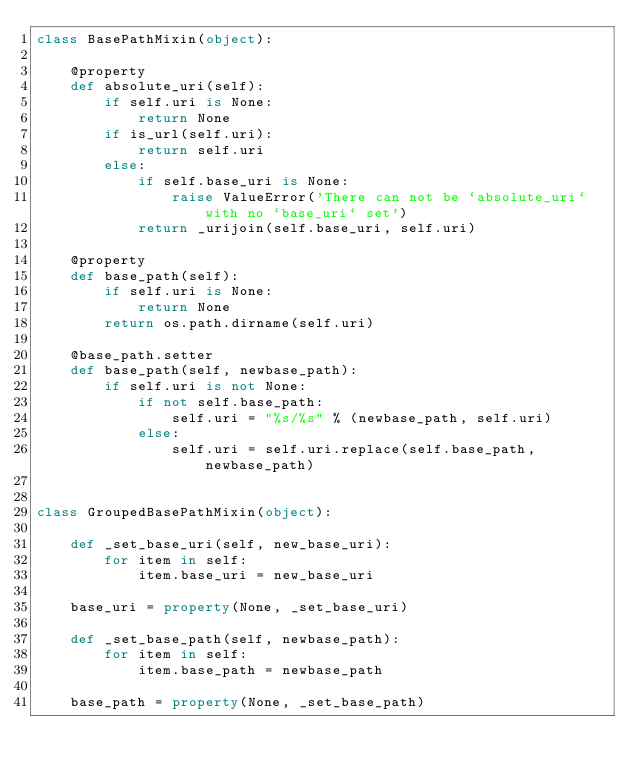<code> <loc_0><loc_0><loc_500><loc_500><_Python_>class BasePathMixin(object):

    @property
    def absolute_uri(self):
        if self.uri is None:
            return None
        if is_url(self.uri):
            return self.uri
        else:
            if self.base_uri is None:
                raise ValueError('There can not be `absolute_uri` with no `base_uri` set')
            return _urijoin(self.base_uri, self.uri)

    @property
    def base_path(self):
        if self.uri is None:
            return None
        return os.path.dirname(self.uri)

    @base_path.setter
    def base_path(self, newbase_path):
        if self.uri is not None:
            if not self.base_path:
                self.uri = "%s/%s" % (newbase_path, self.uri)
            else:
                self.uri = self.uri.replace(self.base_path, newbase_path)


class GroupedBasePathMixin(object):

    def _set_base_uri(self, new_base_uri):
        for item in self:
            item.base_uri = new_base_uri

    base_uri = property(None, _set_base_uri)

    def _set_base_path(self, newbase_path):
        for item in self:
            item.base_path = newbase_path

    base_path = property(None, _set_base_path)
</code> 